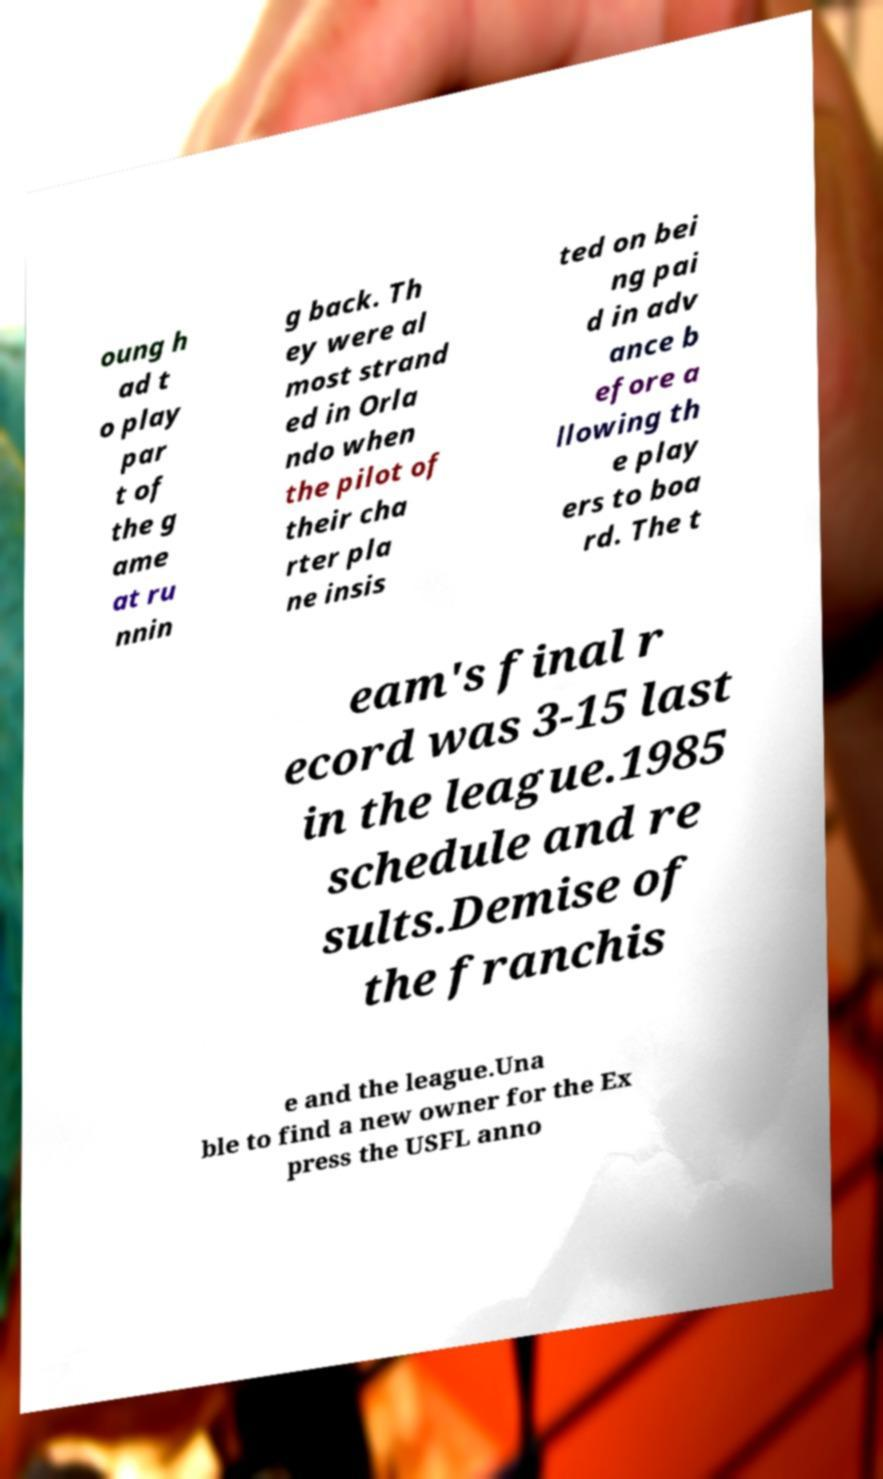Please read and relay the text visible in this image. What does it say? oung h ad t o play par t of the g ame at ru nnin g back. Th ey were al most strand ed in Orla ndo when the pilot of their cha rter pla ne insis ted on bei ng pai d in adv ance b efore a llowing th e play ers to boa rd. The t eam's final r ecord was 3-15 last in the league.1985 schedule and re sults.Demise of the franchis e and the league.Una ble to find a new owner for the Ex press the USFL anno 